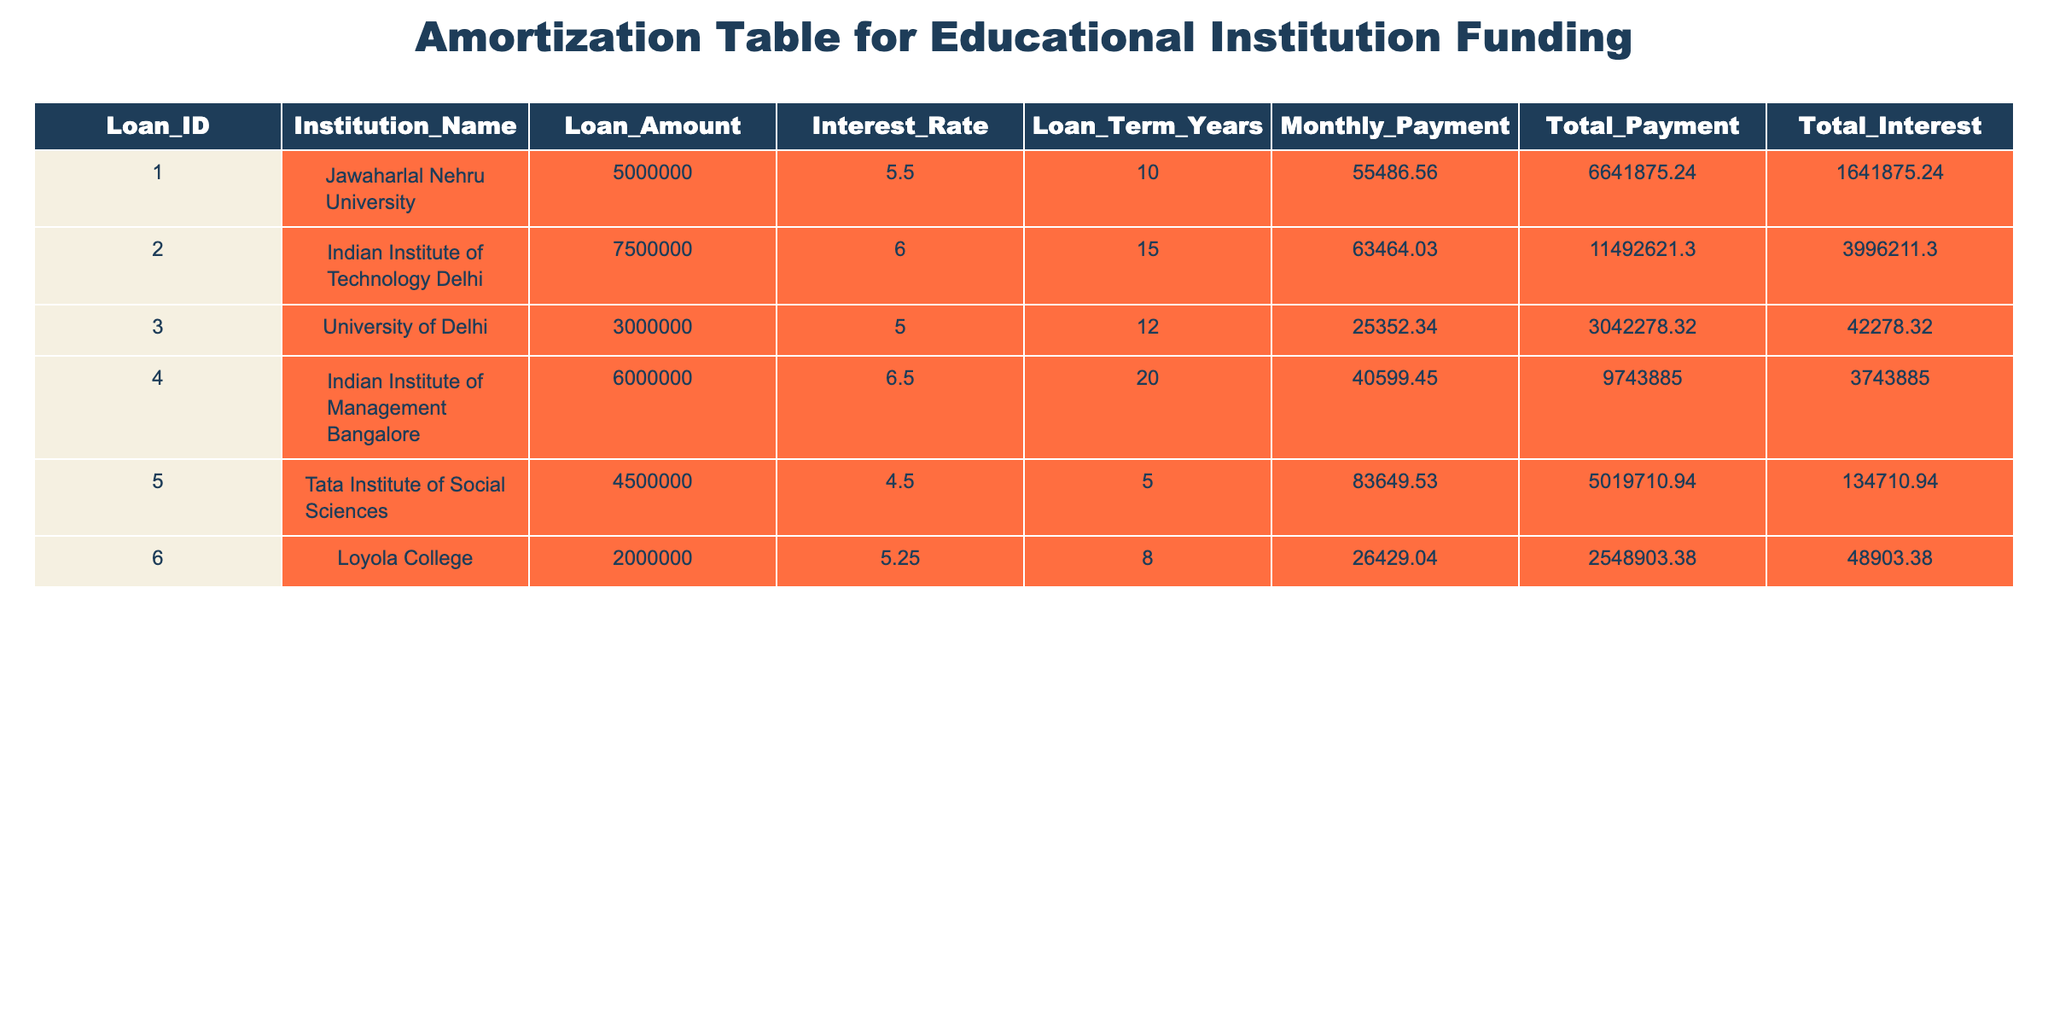What is the loan amount for the Indian Institute of Technology Delhi? The table lists the loan amounts for each institution. Looking at the row for Indian Institute of Technology Delhi, the loan amount is stated directly as 7500000.
Answer: 7500000 Which institution has the highest total interest to be paid? By reviewing the Total Interest column, we can see that the values for total interest for each institution are 1641875.24, 3996211.30, 42278.32, 3743885.00, 134710.94, and 48903.38. The highest value is 3996211.30 for the Indian Institute of Technology Delhi.
Answer: Indian Institute of Technology Delhi What is the total payment for the Jawaharlal Nehru University? The Total Payment column in the table shows the total payment required for each institution. For Jawaharlal Nehru University, this value is 6641875.24.
Answer: 6641875.24 Which institution has the lowest monthly payment? The Monthly Payment can be found for each institution in the corresponding column. The values are 55486.56, 63464.03, 25352.34, 40599.45, 83649.53, and 26429.04. The lowest value is 25352.34 for University of Delhi.
Answer: University of Delhi If an institution has a loan term of 20 years, what is the total payment of the institution with the lowest interest rate? From the table, we identify that the institution with the lowest interest rate is Tata Institute of Social Sciences at 4.5% with a loan term of 5 years, but the only institution with a 20-year term is Indian Institute of Management Bangalore with a total payment of 9743885.00.
Answer: 9743885.00 What is the average loan amount of all institutions listed in the table? To calculate the average, we add the loan amounts: 5000000 + 7500000 + 3000000 + 6000000 + 4500000 + 2000000 = 28000000. Then, we divide by the number of institutions, which is 6. Thus, 28000000 / 6 = 4666666.67.
Answer: 4666666.67 Is the total interest for Loyola College greater than that for University of Delhi? Looking directly at the Total Interest column, Loyola College has a total interest of 48903.38 and University of Delhi has 42278.32. Since 48903.38 is greater than 42278.32, the answer is yes.
Answer: Yes What is the difference in total payment between Tata Institute of Social Sciences and Indian Institute of Management Bangalore? The total payment for Tata Institute of Social Sciences is 5019710.94 and for Indian Institute of Management Bangalore it is 9743885.00. To find the difference, we subtract the lower from the higher: 9743885.00 - 5019710.94 = 4724174.06.
Answer: 4724174.06 